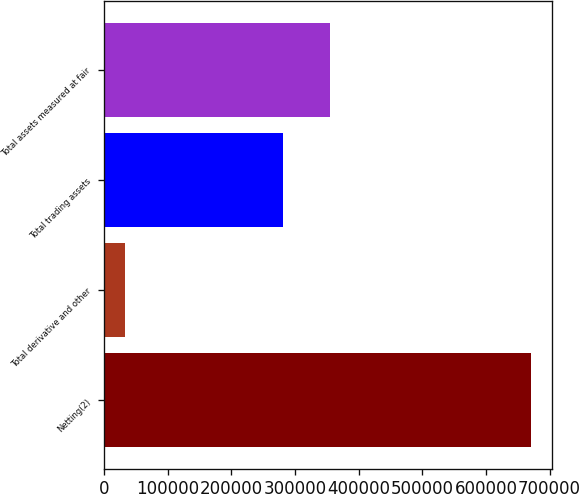Convert chart to OTSL. <chart><loc_0><loc_0><loc_500><loc_500><bar_chart><fcel>Netting(2)<fcel>Total derivative and other<fcel>Total trading assets<fcel>Total assets measured at fair<nl><fcel>670551<fcel>32467<fcel>280744<fcel>355556<nl></chart> 